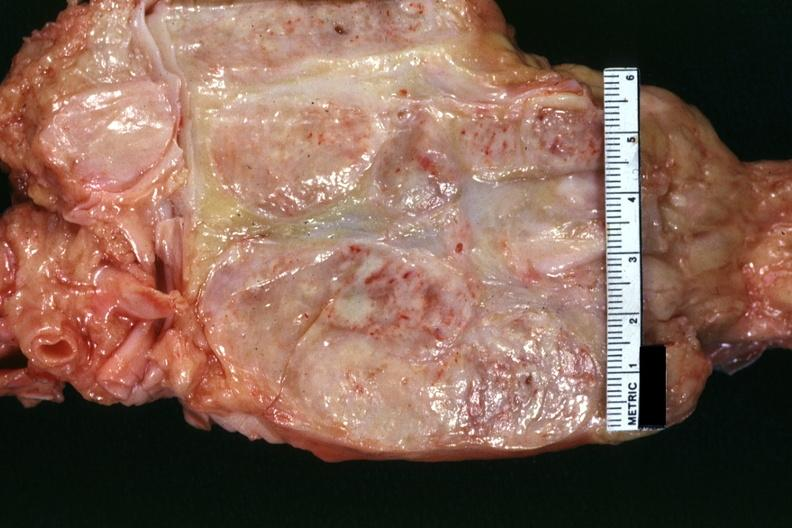what does this image show?
Answer the question using a single word or phrase. Excellent example cut surface of nodes seen externally in slide shows matting and focal necrosis 